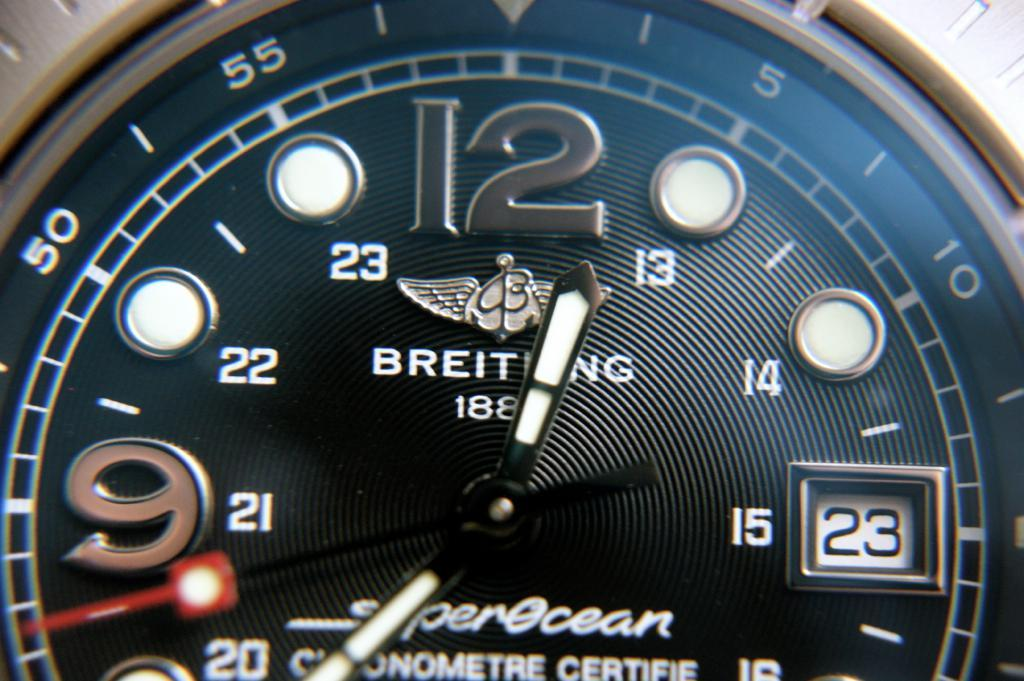<image>
Offer a succinct explanation of the picture presented. the number 12 is on the top of the watch 